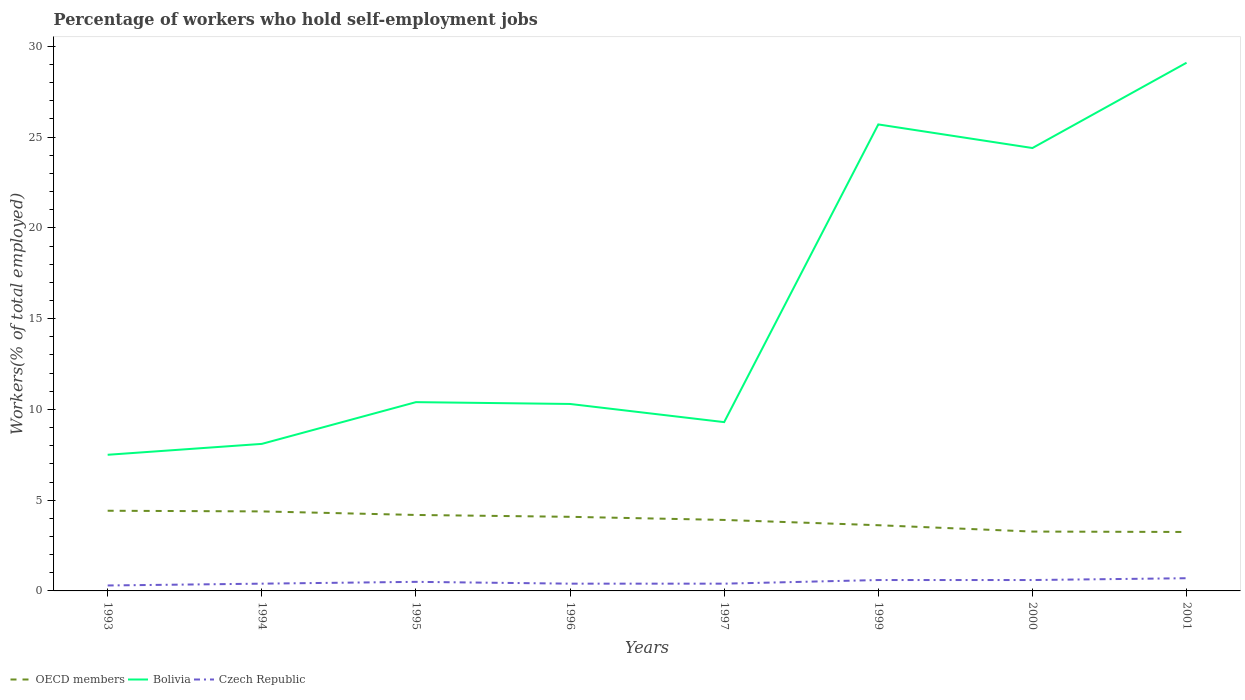How many different coloured lines are there?
Keep it short and to the point. 3. Across all years, what is the maximum percentage of self-employed workers in OECD members?
Keep it short and to the point. 3.25. In which year was the percentage of self-employed workers in OECD members maximum?
Provide a succinct answer. 2001. What is the total percentage of self-employed workers in Bolivia in the graph?
Your answer should be very brief. -14. What is the difference between the highest and the second highest percentage of self-employed workers in Czech Republic?
Ensure brevity in your answer.  0.4. What is the difference between the highest and the lowest percentage of self-employed workers in Czech Republic?
Give a very brief answer. 4. How many lines are there?
Offer a very short reply. 3. How many years are there in the graph?
Offer a very short reply. 8. What is the difference between two consecutive major ticks on the Y-axis?
Your answer should be compact. 5. Are the values on the major ticks of Y-axis written in scientific E-notation?
Offer a very short reply. No. Does the graph contain grids?
Your answer should be compact. No. Where does the legend appear in the graph?
Your answer should be compact. Bottom left. How are the legend labels stacked?
Your response must be concise. Horizontal. What is the title of the graph?
Offer a terse response. Percentage of workers who hold self-employment jobs. What is the label or title of the Y-axis?
Provide a short and direct response. Workers(% of total employed). What is the Workers(% of total employed) in OECD members in 1993?
Provide a short and direct response. 4.42. What is the Workers(% of total employed) in Bolivia in 1993?
Make the answer very short. 7.5. What is the Workers(% of total employed) of Czech Republic in 1993?
Your answer should be compact. 0.3. What is the Workers(% of total employed) in OECD members in 1994?
Provide a short and direct response. 4.38. What is the Workers(% of total employed) in Bolivia in 1994?
Provide a short and direct response. 8.1. What is the Workers(% of total employed) of Czech Republic in 1994?
Offer a terse response. 0.4. What is the Workers(% of total employed) in OECD members in 1995?
Give a very brief answer. 4.18. What is the Workers(% of total employed) of Bolivia in 1995?
Your answer should be very brief. 10.4. What is the Workers(% of total employed) in OECD members in 1996?
Make the answer very short. 4.08. What is the Workers(% of total employed) in Bolivia in 1996?
Provide a short and direct response. 10.3. What is the Workers(% of total employed) in Czech Republic in 1996?
Your answer should be compact. 0.4. What is the Workers(% of total employed) in OECD members in 1997?
Offer a terse response. 3.91. What is the Workers(% of total employed) of Bolivia in 1997?
Offer a very short reply. 9.3. What is the Workers(% of total employed) in Czech Republic in 1997?
Your answer should be very brief. 0.4. What is the Workers(% of total employed) of OECD members in 1999?
Make the answer very short. 3.62. What is the Workers(% of total employed) in Bolivia in 1999?
Provide a succinct answer. 25.7. What is the Workers(% of total employed) in Czech Republic in 1999?
Give a very brief answer. 0.6. What is the Workers(% of total employed) in OECD members in 2000?
Your answer should be very brief. 3.27. What is the Workers(% of total employed) of Bolivia in 2000?
Your answer should be very brief. 24.4. What is the Workers(% of total employed) in Czech Republic in 2000?
Ensure brevity in your answer.  0.6. What is the Workers(% of total employed) in OECD members in 2001?
Offer a very short reply. 3.25. What is the Workers(% of total employed) in Bolivia in 2001?
Provide a short and direct response. 29.1. What is the Workers(% of total employed) in Czech Republic in 2001?
Make the answer very short. 0.7. Across all years, what is the maximum Workers(% of total employed) in OECD members?
Provide a short and direct response. 4.42. Across all years, what is the maximum Workers(% of total employed) of Bolivia?
Ensure brevity in your answer.  29.1. Across all years, what is the maximum Workers(% of total employed) of Czech Republic?
Ensure brevity in your answer.  0.7. Across all years, what is the minimum Workers(% of total employed) of OECD members?
Give a very brief answer. 3.25. Across all years, what is the minimum Workers(% of total employed) in Czech Republic?
Your answer should be very brief. 0.3. What is the total Workers(% of total employed) of OECD members in the graph?
Your answer should be compact. 31.11. What is the total Workers(% of total employed) in Bolivia in the graph?
Your response must be concise. 124.8. What is the total Workers(% of total employed) in Czech Republic in the graph?
Make the answer very short. 3.9. What is the difference between the Workers(% of total employed) in OECD members in 1993 and that in 1994?
Provide a succinct answer. 0.04. What is the difference between the Workers(% of total employed) in Bolivia in 1993 and that in 1994?
Your answer should be compact. -0.6. What is the difference between the Workers(% of total employed) in Czech Republic in 1993 and that in 1994?
Your answer should be compact. -0.1. What is the difference between the Workers(% of total employed) of OECD members in 1993 and that in 1995?
Provide a succinct answer. 0.23. What is the difference between the Workers(% of total employed) of OECD members in 1993 and that in 1996?
Offer a very short reply. 0.33. What is the difference between the Workers(% of total employed) of Czech Republic in 1993 and that in 1996?
Your answer should be compact. -0.1. What is the difference between the Workers(% of total employed) in OECD members in 1993 and that in 1997?
Offer a terse response. 0.51. What is the difference between the Workers(% of total employed) in OECD members in 1993 and that in 1999?
Offer a very short reply. 0.8. What is the difference between the Workers(% of total employed) of Bolivia in 1993 and that in 1999?
Provide a succinct answer. -18.2. What is the difference between the Workers(% of total employed) of OECD members in 1993 and that in 2000?
Provide a short and direct response. 1.15. What is the difference between the Workers(% of total employed) in Bolivia in 1993 and that in 2000?
Keep it short and to the point. -16.9. What is the difference between the Workers(% of total employed) of Czech Republic in 1993 and that in 2000?
Offer a very short reply. -0.3. What is the difference between the Workers(% of total employed) in OECD members in 1993 and that in 2001?
Your response must be concise. 1.17. What is the difference between the Workers(% of total employed) of Bolivia in 1993 and that in 2001?
Offer a very short reply. -21.6. What is the difference between the Workers(% of total employed) in Czech Republic in 1993 and that in 2001?
Offer a very short reply. -0.4. What is the difference between the Workers(% of total employed) of OECD members in 1994 and that in 1995?
Offer a very short reply. 0.2. What is the difference between the Workers(% of total employed) of Bolivia in 1994 and that in 1995?
Your response must be concise. -2.3. What is the difference between the Workers(% of total employed) of OECD members in 1994 and that in 1996?
Provide a short and direct response. 0.3. What is the difference between the Workers(% of total employed) in Bolivia in 1994 and that in 1996?
Provide a short and direct response. -2.2. What is the difference between the Workers(% of total employed) of OECD members in 1994 and that in 1997?
Ensure brevity in your answer.  0.47. What is the difference between the Workers(% of total employed) of OECD members in 1994 and that in 1999?
Ensure brevity in your answer.  0.76. What is the difference between the Workers(% of total employed) in Bolivia in 1994 and that in 1999?
Your response must be concise. -17.6. What is the difference between the Workers(% of total employed) in Czech Republic in 1994 and that in 1999?
Offer a very short reply. -0.2. What is the difference between the Workers(% of total employed) of OECD members in 1994 and that in 2000?
Give a very brief answer. 1.11. What is the difference between the Workers(% of total employed) of Bolivia in 1994 and that in 2000?
Your answer should be very brief. -16.3. What is the difference between the Workers(% of total employed) of OECD members in 1994 and that in 2001?
Provide a short and direct response. 1.13. What is the difference between the Workers(% of total employed) in Czech Republic in 1994 and that in 2001?
Ensure brevity in your answer.  -0.3. What is the difference between the Workers(% of total employed) in OECD members in 1995 and that in 1996?
Ensure brevity in your answer.  0.1. What is the difference between the Workers(% of total employed) in OECD members in 1995 and that in 1997?
Your answer should be very brief. 0.27. What is the difference between the Workers(% of total employed) of Bolivia in 1995 and that in 1997?
Provide a short and direct response. 1.1. What is the difference between the Workers(% of total employed) in OECD members in 1995 and that in 1999?
Provide a short and direct response. 0.57. What is the difference between the Workers(% of total employed) in Bolivia in 1995 and that in 1999?
Offer a terse response. -15.3. What is the difference between the Workers(% of total employed) of OECD members in 1995 and that in 2000?
Your response must be concise. 0.92. What is the difference between the Workers(% of total employed) of Bolivia in 1995 and that in 2000?
Your response must be concise. -14. What is the difference between the Workers(% of total employed) of Czech Republic in 1995 and that in 2000?
Make the answer very short. -0.1. What is the difference between the Workers(% of total employed) of OECD members in 1995 and that in 2001?
Ensure brevity in your answer.  0.94. What is the difference between the Workers(% of total employed) in Bolivia in 1995 and that in 2001?
Keep it short and to the point. -18.7. What is the difference between the Workers(% of total employed) of OECD members in 1996 and that in 1997?
Offer a very short reply. 0.17. What is the difference between the Workers(% of total employed) in Bolivia in 1996 and that in 1997?
Keep it short and to the point. 1. What is the difference between the Workers(% of total employed) in OECD members in 1996 and that in 1999?
Keep it short and to the point. 0.46. What is the difference between the Workers(% of total employed) of Bolivia in 1996 and that in 1999?
Provide a succinct answer. -15.4. What is the difference between the Workers(% of total employed) of OECD members in 1996 and that in 2000?
Keep it short and to the point. 0.81. What is the difference between the Workers(% of total employed) in Bolivia in 1996 and that in 2000?
Offer a very short reply. -14.1. What is the difference between the Workers(% of total employed) in Czech Republic in 1996 and that in 2000?
Your answer should be very brief. -0.2. What is the difference between the Workers(% of total employed) in OECD members in 1996 and that in 2001?
Offer a terse response. 0.83. What is the difference between the Workers(% of total employed) in Bolivia in 1996 and that in 2001?
Keep it short and to the point. -18.8. What is the difference between the Workers(% of total employed) of OECD members in 1997 and that in 1999?
Offer a very short reply. 0.29. What is the difference between the Workers(% of total employed) in Bolivia in 1997 and that in 1999?
Offer a very short reply. -16.4. What is the difference between the Workers(% of total employed) in OECD members in 1997 and that in 2000?
Offer a terse response. 0.64. What is the difference between the Workers(% of total employed) of Bolivia in 1997 and that in 2000?
Ensure brevity in your answer.  -15.1. What is the difference between the Workers(% of total employed) of Czech Republic in 1997 and that in 2000?
Provide a succinct answer. -0.2. What is the difference between the Workers(% of total employed) of OECD members in 1997 and that in 2001?
Give a very brief answer. 0.66. What is the difference between the Workers(% of total employed) in Bolivia in 1997 and that in 2001?
Your answer should be very brief. -19.8. What is the difference between the Workers(% of total employed) of Czech Republic in 1997 and that in 2001?
Your answer should be compact. -0.3. What is the difference between the Workers(% of total employed) in OECD members in 1999 and that in 2000?
Provide a succinct answer. 0.35. What is the difference between the Workers(% of total employed) in Bolivia in 1999 and that in 2000?
Offer a very short reply. 1.3. What is the difference between the Workers(% of total employed) in OECD members in 1999 and that in 2001?
Offer a very short reply. 0.37. What is the difference between the Workers(% of total employed) in OECD members in 2000 and that in 2001?
Offer a terse response. 0.02. What is the difference between the Workers(% of total employed) of Czech Republic in 2000 and that in 2001?
Your answer should be compact. -0.1. What is the difference between the Workers(% of total employed) in OECD members in 1993 and the Workers(% of total employed) in Bolivia in 1994?
Keep it short and to the point. -3.68. What is the difference between the Workers(% of total employed) in OECD members in 1993 and the Workers(% of total employed) in Czech Republic in 1994?
Ensure brevity in your answer.  4.02. What is the difference between the Workers(% of total employed) of OECD members in 1993 and the Workers(% of total employed) of Bolivia in 1995?
Offer a terse response. -5.98. What is the difference between the Workers(% of total employed) in OECD members in 1993 and the Workers(% of total employed) in Czech Republic in 1995?
Your answer should be compact. 3.92. What is the difference between the Workers(% of total employed) of Bolivia in 1993 and the Workers(% of total employed) of Czech Republic in 1995?
Provide a succinct answer. 7. What is the difference between the Workers(% of total employed) of OECD members in 1993 and the Workers(% of total employed) of Bolivia in 1996?
Ensure brevity in your answer.  -5.88. What is the difference between the Workers(% of total employed) in OECD members in 1993 and the Workers(% of total employed) in Czech Republic in 1996?
Ensure brevity in your answer.  4.02. What is the difference between the Workers(% of total employed) in Bolivia in 1993 and the Workers(% of total employed) in Czech Republic in 1996?
Offer a terse response. 7.1. What is the difference between the Workers(% of total employed) of OECD members in 1993 and the Workers(% of total employed) of Bolivia in 1997?
Make the answer very short. -4.88. What is the difference between the Workers(% of total employed) of OECD members in 1993 and the Workers(% of total employed) of Czech Republic in 1997?
Your response must be concise. 4.02. What is the difference between the Workers(% of total employed) of OECD members in 1993 and the Workers(% of total employed) of Bolivia in 1999?
Your answer should be very brief. -21.28. What is the difference between the Workers(% of total employed) of OECD members in 1993 and the Workers(% of total employed) of Czech Republic in 1999?
Make the answer very short. 3.82. What is the difference between the Workers(% of total employed) in Bolivia in 1993 and the Workers(% of total employed) in Czech Republic in 1999?
Provide a short and direct response. 6.9. What is the difference between the Workers(% of total employed) in OECD members in 1993 and the Workers(% of total employed) in Bolivia in 2000?
Your answer should be compact. -19.98. What is the difference between the Workers(% of total employed) in OECD members in 1993 and the Workers(% of total employed) in Czech Republic in 2000?
Offer a very short reply. 3.82. What is the difference between the Workers(% of total employed) in OECD members in 1993 and the Workers(% of total employed) in Bolivia in 2001?
Provide a short and direct response. -24.68. What is the difference between the Workers(% of total employed) of OECD members in 1993 and the Workers(% of total employed) of Czech Republic in 2001?
Offer a very short reply. 3.72. What is the difference between the Workers(% of total employed) in OECD members in 1994 and the Workers(% of total employed) in Bolivia in 1995?
Offer a terse response. -6.02. What is the difference between the Workers(% of total employed) in OECD members in 1994 and the Workers(% of total employed) in Czech Republic in 1995?
Your answer should be very brief. 3.88. What is the difference between the Workers(% of total employed) of Bolivia in 1994 and the Workers(% of total employed) of Czech Republic in 1995?
Your response must be concise. 7.6. What is the difference between the Workers(% of total employed) in OECD members in 1994 and the Workers(% of total employed) in Bolivia in 1996?
Keep it short and to the point. -5.92. What is the difference between the Workers(% of total employed) of OECD members in 1994 and the Workers(% of total employed) of Czech Republic in 1996?
Your response must be concise. 3.98. What is the difference between the Workers(% of total employed) in Bolivia in 1994 and the Workers(% of total employed) in Czech Republic in 1996?
Your answer should be compact. 7.7. What is the difference between the Workers(% of total employed) in OECD members in 1994 and the Workers(% of total employed) in Bolivia in 1997?
Make the answer very short. -4.92. What is the difference between the Workers(% of total employed) of OECD members in 1994 and the Workers(% of total employed) of Czech Republic in 1997?
Provide a short and direct response. 3.98. What is the difference between the Workers(% of total employed) in Bolivia in 1994 and the Workers(% of total employed) in Czech Republic in 1997?
Provide a short and direct response. 7.7. What is the difference between the Workers(% of total employed) in OECD members in 1994 and the Workers(% of total employed) in Bolivia in 1999?
Keep it short and to the point. -21.32. What is the difference between the Workers(% of total employed) in OECD members in 1994 and the Workers(% of total employed) in Czech Republic in 1999?
Keep it short and to the point. 3.78. What is the difference between the Workers(% of total employed) in OECD members in 1994 and the Workers(% of total employed) in Bolivia in 2000?
Provide a short and direct response. -20.02. What is the difference between the Workers(% of total employed) in OECD members in 1994 and the Workers(% of total employed) in Czech Republic in 2000?
Your answer should be compact. 3.78. What is the difference between the Workers(% of total employed) in Bolivia in 1994 and the Workers(% of total employed) in Czech Republic in 2000?
Your response must be concise. 7.5. What is the difference between the Workers(% of total employed) of OECD members in 1994 and the Workers(% of total employed) of Bolivia in 2001?
Make the answer very short. -24.72. What is the difference between the Workers(% of total employed) of OECD members in 1994 and the Workers(% of total employed) of Czech Republic in 2001?
Keep it short and to the point. 3.68. What is the difference between the Workers(% of total employed) in OECD members in 1995 and the Workers(% of total employed) in Bolivia in 1996?
Provide a succinct answer. -6.12. What is the difference between the Workers(% of total employed) in OECD members in 1995 and the Workers(% of total employed) in Czech Republic in 1996?
Provide a succinct answer. 3.78. What is the difference between the Workers(% of total employed) in OECD members in 1995 and the Workers(% of total employed) in Bolivia in 1997?
Provide a short and direct response. -5.12. What is the difference between the Workers(% of total employed) in OECD members in 1995 and the Workers(% of total employed) in Czech Republic in 1997?
Your answer should be compact. 3.78. What is the difference between the Workers(% of total employed) of OECD members in 1995 and the Workers(% of total employed) of Bolivia in 1999?
Provide a short and direct response. -21.52. What is the difference between the Workers(% of total employed) of OECD members in 1995 and the Workers(% of total employed) of Czech Republic in 1999?
Provide a short and direct response. 3.58. What is the difference between the Workers(% of total employed) of Bolivia in 1995 and the Workers(% of total employed) of Czech Republic in 1999?
Provide a short and direct response. 9.8. What is the difference between the Workers(% of total employed) of OECD members in 1995 and the Workers(% of total employed) of Bolivia in 2000?
Offer a terse response. -20.22. What is the difference between the Workers(% of total employed) of OECD members in 1995 and the Workers(% of total employed) of Czech Republic in 2000?
Provide a short and direct response. 3.58. What is the difference between the Workers(% of total employed) in OECD members in 1995 and the Workers(% of total employed) in Bolivia in 2001?
Give a very brief answer. -24.92. What is the difference between the Workers(% of total employed) in OECD members in 1995 and the Workers(% of total employed) in Czech Republic in 2001?
Offer a terse response. 3.48. What is the difference between the Workers(% of total employed) in OECD members in 1996 and the Workers(% of total employed) in Bolivia in 1997?
Your answer should be very brief. -5.22. What is the difference between the Workers(% of total employed) in OECD members in 1996 and the Workers(% of total employed) in Czech Republic in 1997?
Offer a terse response. 3.68. What is the difference between the Workers(% of total employed) of Bolivia in 1996 and the Workers(% of total employed) of Czech Republic in 1997?
Your answer should be compact. 9.9. What is the difference between the Workers(% of total employed) of OECD members in 1996 and the Workers(% of total employed) of Bolivia in 1999?
Your answer should be very brief. -21.62. What is the difference between the Workers(% of total employed) in OECD members in 1996 and the Workers(% of total employed) in Czech Republic in 1999?
Offer a terse response. 3.48. What is the difference between the Workers(% of total employed) of Bolivia in 1996 and the Workers(% of total employed) of Czech Republic in 1999?
Offer a very short reply. 9.7. What is the difference between the Workers(% of total employed) in OECD members in 1996 and the Workers(% of total employed) in Bolivia in 2000?
Keep it short and to the point. -20.32. What is the difference between the Workers(% of total employed) of OECD members in 1996 and the Workers(% of total employed) of Czech Republic in 2000?
Provide a short and direct response. 3.48. What is the difference between the Workers(% of total employed) in Bolivia in 1996 and the Workers(% of total employed) in Czech Republic in 2000?
Your answer should be very brief. 9.7. What is the difference between the Workers(% of total employed) of OECD members in 1996 and the Workers(% of total employed) of Bolivia in 2001?
Ensure brevity in your answer.  -25.02. What is the difference between the Workers(% of total employed) in OECD members in 1996 and the Workers(% of total employed) in Czech Republic in 2001?
Provide a short and direct response. 3.38. What is the difference between the Workers(% of total employed) of OECD members in 1997 and the Workers(% of total employed) of Bolivia in 1999?
Your answer should be very brief. -21.79. What is the difference between the Workers(% of total employed) in OECD members in 1997 and the Workers(% of total employed) in Czech Republic in 1999?
Your response must be concise. 3.31. What is the difference between the Workers(% of total employed) of OECD members in 1997 and the Workers(% of total employed) of Bolivia in 2000?
Your response must be concise. -20.49. What is the difference between the Workers(% of total employed) of OECD members in 1997 and the Workers(% of total employed) of Czech Republic in 2000?
Your answer should be compact. 3.31. What is the difference between the Workers(% of total employed) in OECD members in 1997 and the Workers(% of total employed) in Bolivia in 2001?
Ensure brevity in your answer.  -25.19. What is the difference between the Workers(% of total employed) of OECD members in 1997 and the Workers(% of total employed) of Czech Republic in 2001?
Offer a terse response. 3.21. What is the difference between the Workers(% of total employed) of Bolivia in 1997 and the Workers(% of total employed) of Czech Republic in 2001?
Provide a short and direct response. 8.6. What is the difference between the Workers(% of total employed) of OECD members in 1999 and the Workers(% of total employed) of Bolivia in 2000?
Your answer should be compact. -20.78. What is the difference between the Workers(% of total employed) in OECD members in 1999 and the Workers(% of total employed) in Czech Republic in 2000?
Make the answer very short. 3.02. What is the difference between the Workers(% of total employed) in Bolivia in 1999 and the Workers(% of total employed) in Czech Republic in 2000?
Make the answer very short. 25.1. What is the difference between the Workers(% of total employed) of OECD members in 1999 and the Workers(% of total employed) of Bolivia in 2001?
Ensure brevity in your answer.  -25.48. What is the difference between the Workers(% of total employed) of OECD members in 1999 and the Workers(% of total employed) of Czech Republic in 2001?
Your answer should be very brief. 2.92. What is the difference between the Workers(% of total employed) of Bolivia in 1999 and the Workers(% of total employed) of Czech Republic in 2001?
Provide a short and direct response. 25. What is the difference between the Workers(% of total employed) in OECD members in 2000 and the Workers(% of total employed) in Bolivia in 2001?
Ensure brevity in your answer.  -25.83. What is the difference between the Workers(% of total employed) of OECD members in 2000 and the Workers(% of total employed) of Czech Republic in 2001?
Provide a succinct answer. 2.57. What is the difference between the Workers(% of total employed) of Bolivia in 2000 and the Workers(% of total employed) of Czech Republic in 2001?
Keep it short and to the point. 23.7. What is the average Workers(% of total employed) of OECD members per year?
Keep it short and to the point. 3.89. What is the average Workers(% of total employed) in Czech Republic per year?
Keep it short and to the point. 0.49. In the year 1993, what is the difference between the Workers(% of total employed) of OECD members and Workers(% of total employed) of Bolivia?
Provide a succinct answer. -3.08. In the year 1993, what is the difference between the Workers(% of total employed) of OECD members and Workers(% of total employed) of Czech Republic?
Your answer should be very brief. 4.12. In the year 1994, what is the difference between the Workers(% of total employed) of OECD members and Workers(% of total employed) of Bolivia?
Give a very brief answer. -3.72. In the year 1994, what is the difference between the Workers(% of total employed) of OECD members and Workers(% of total employed) of Czech Republic?
Your response must be concise. 3.98. In the year 1994, what is the difference between the Workers(% of total employed) of Bolivia and Workers(% of total employed) of Czech Republic?
Your answer should be very brief. 7.7. In the year 1995, what is the difference between the Workers(% of total employed) of OECD members and Workers(% of total employed) of Bolivia?
Provide a succinct answer. -6.22. In the year 1995, what is the difference between the Workers(% of total employed) in OECD members and Workers(% of total employed) in Czech Republic?
Keep it short and to the point. 3.68. In the year 1996, what is the difference between the Workers(% of total employed) of OECD members and Workers(% of total employed) of Bolivia?
Give a very brief answer. -6.22. In the year 1996, what is the difference between the Workers(% of total employed) of OECD members and Workers(% of total employed) of Czech Republic?
Give a very brief answer. 3.68. In the year 1997, what is the difference between the Workers(% of total employed) of OECD members and Workers(% of total employed) of Bolivia?
Your answer should be very brief. -5.39. In the year 1997, what is the difference between the Workers(% of total employed) of OECD members and Workers(% of total employed) of Czech Republic?
Your answer should be compact. 3.51. In the year 1997, what is the difference between the Workers(% of total employed) of Bolivia and Workers(% of total employed) of Czech Republic?
Offer a very short reply. 8.9. In the year 1999, what is the difference between the Workers(% of total employed) of OECD members and Workers(% of total employed) of Bolivia?
Give a very brief answer. -22.08. In the year 1999, what is the difference between the Workers(% of total employed) in OECD members and Workers(% of total employed) in Czech Republic?
Your response must be concise. 3.02. In the year 1999, what is the difference between the Workers(% of total employed) of Bolivia and Workers(% of total employed) of Czech Republic?
Provide a succinct answer. 25.1. In the year 2000, what is the difference between the Workers(% of total employed) of OECD members and Workers(% of total employed) of Bolivia?
Your answer should be very brief. -21.13. In the year 2000, what is the difference between the Workers(% of total employed) in OECD members and Workers(% of total employed) in Czech Republic?
Keep it short and to the point. 2.67. In the year 2000, what is the difference between the Workers(% of total employed) of Bolivia and Workers(% of total employed) of Czech Republic?
Ensure brevity in your answer.  23.8. In the year 2001, what is the difference between the Workers(% of total employed) in OECD members and Workers(% of total employed) in Bolivia?
Your response must be concise. -25.85. In the year 2001, what is the difference between the Workers(% of total employed) of OECD members and Workers(% of total employed) of Czech Republic?
Provide a short and direct response. 2.55. In the year 2001, what is the difference between the Workers(% of total employed) of Bolivia and Workers(% of total employed) of Czech Republic?
Provide a succinct answer. 28.4. What is the ratio of the Workers(% of total employed) in OECD members in 1993 to that in 1994?
Your answer should be compact. 1.01. What is the ratio of the Workers(% of total employed) in Bolivia in 1993 to that in 1994?
Your answer should be compact. 0.93. What is the ratio of the Workers(% of total employed) of Czech Republic in 1993 to that in 1994?
Offer a terse response. 0.75. What is the ratio of the Workers(% of total employed) in OECD members in 1993 to that in 1995?
Ensure brevity in your answer.  1.06. What is the ratio of the Workers(% of total employed) in Bolivia in 1993 to that in 1995?
Offer a very short reply. 0.72. What is the ratio of the Workers(% of total employed) in Czech Republic in 1993 to that in 1995?
Offer a terse response. 0.6. What is the ratio of the Workers(% of total employed) of OECD members in 1993 to that in 1996?
Give a very brief answer. 1.08. What is the ratio of the Workers(% of total employed) in Bolivia in 1993 to that in 1996?
Your answer should be compact. 0.73. What is the ratio of the Workers(% of total employed) in OECD members in 1993 to that in 1997?
Your answer should be very brief. 1.13. What is the ratio of the Workers(% of total employed) in Bolivia in 1993 to that in 1997?
Your answer should be very brief. 0.81. What is the ratio of the Workers(% of total employed) of Czech Republic in 1993 to that in 1997?
Give a very brief answer. 0.75. What is the ratio of the Workers(% of total employed) of OECD members in 1993 to that in 1999?
Make the answer very short. 1.22. What is the ratio of the Workers(% of total employed) in Bolivia in 1993 to that in 1999?
Provide a short and direct response. 0.29. What is the ratio of the Workers(% of total employed) in Czech Republic in 1993 to that in 1999?
Ensure brevity in your answer.  0.5. What is the ratio of the Workers(% of total employed) of OECD members in 1993 to that in 2000?
Provide a short and direct response. 1.35. What is the ratio of the Workers(% of total employed) in Bolivia in 1993 to that in 2000?
Keep it short and to the point. 0.31. What is the ratio of the Workers(% of total employed) in OECD members in 1993 to that in 2001?
Your response must be concise. 1.36. What is the ratio of the Workers(% of total employed) in Bolivia in 1993 to that in 2001?
Your response must be concise. 0.26. What is the ratio of the Workers(% of total employed) of Czech Republic in 1993 to that in 2001?
Offer a terse response. 0.43. What is the ratio of the Workers(% of total employed) in OECD members in 1994 to that in 1995?
Your response must be concise. 1.05. What is the ratio of the Workers(% of total employed) of Bolivia in 1994 to that in 1995?
Provide a short and direct response. 0.78. What is the ratio of the Workers(% of total employed) of Czech Republic in 1994 to that in 1995?
Give a very brief answer. 0.8. What is the ratio of the Workers(% of total employed) of OECD members in 1994 to that in 1996?
Ensure brevity in your answer.  1.07. What is the ratio of the Workers(% of total employed) of Bolivia in 1994 to that in 1996?
Your response must be concise. 0.79. What is the ratio of the Workers(% of total employed) in Czech Republic in 1994 to that in 1996?
Provide a short and direct response. 1. What is the ratio of the Workers(% of total employed) of OECD members in 1994 to that in 1997?
Make the answer very short. 1.12. What is the ratio of the Workers(% of total employed) of Bolivia in 1994 to that in 1997?
Make the answer very short. 0.87. What is the ratio of the Workers(% of total employed) of Czech Republic in 1994 to that in 1997?
Give a very brief answer. 1. What is the ratio of the Workers(% of total employed) of OECD members in 1994 to that in 1999?
Provide a short and direct response. 1.21. What is the ratio of the Workers(% of total employed) of Bolivia in 1994 to that in 1999?
Your response must be concise. 0.32. What is the ratio of the Workers(% of total employed) of OECD members in 1994 to that in 2000?
Your answer should be compact. 1.34. What is the ratio of the Workers(% of total employed) of Bolivia in 1994 to that in 2000?
Your answer should be compact. 0.33. What is the ratio of the Workers(% of total employed) in Czech Republic in 1994 to that in 2000?
Your answer should be very brief. 0.67. What is the ratio of the Workers(% of total employed) of OECD members in 1994 to that in 2001?
Provide a succinct answer. 1.35. What is the ratio of the Workers(% of total employed) in Bolivia in 1994 to that in 2001?
Provide a short and direct response. 0.28. What is the ratio of the Workers(% of total employed) in OECD members in 1995 to that in 1996?
Offer a terse response. 1.02. What is the ratio of the Workers(% of total employed) in Bolivia in 1995 to that in 1996?
Your answer should be very brief. 1.01. What is the ratio of the Workers(% of total employed) in Czech Republic in 1995 to that in 1996?
Offer a very short reply. 1.25. What is the ratio of the Workers(% of total employed) of OECD members in 1995 to that in 1997?
Provide a succinct answer. 1.07. What is the ratio of the Workers(% of total employed) in Bolivia in 1995 to that in 1997?
Give a very brief answer. 1.12. What is the ratio of the Workers(% of total employed) in OECD members in 1995 to that in 1999?
Provide a short and direct response. 1.16. What is the ratio of the Workers(% of total employed) in Bolivia in 1995 to that in 1999?
Keep it short and to the point. 0.4. What is the ratio of the Workers(% of total employed) in Czech Republic in 1995 to that in 1999?
Keep it short and to the point. 0.83. What is the ratio of the Workers(% of total employed) of OECD members in 1995 to that in 2000?
Your response must be concise. 1.28. What is the ratio of the Workers(% of total employed) of Bolivia in 1995 to that in 2000?
Provide a short and direct response. 0.43. What is the ratio of the Workers(% of total employed) in OECD members in 1995 to that in 2001?
Your answer should be very brief. 1.29. What is the ratio of the Workers(% of total employed) of Bolivia in 1995 to that in 2001?
Your answer should be compact. 0.36. What is the ratio of the Workers(% of total employed) of OECD members in 1996 to that in 1997?
Make the answer very short. 1.04. What is the ratio of the Workers(% of total employed) in Bolivia in 1996 to that in 1997?
Keep it short and to the point. 1.11. What is the ratio of the Workers(% of total employed) in Czech Republic in 1996 to that in 1997?
Your response must be concise. 1. What is the ratio of the Workers(% of total employed) of OECD members in 1996 to that in 1999?
Your answer should be very brief. 1.13. What is the ratio of the Workers(% of total employed) of Bolivia in 1996 to that in 1999?
Offer a terse response. 0.4. What is the ratio of the Workers(% of total employed) in Czech Republic in 1996 to that in 1999?
Offer a very short reply. 0.67. What is the ratio of the Workers(% of total employed) of OECD members in 1996 to that in 2000?
Your response must be concise. 1.25. What is the ratio of the Workers(% of total employed) in Bolivia in 1996 to that in 2000?
Offer a very short reply. 0.42. What is the ratio of the Workers(% of total employed) in Czech Republic in 1996 to that in 2000?
Ensure brevity in your answer.  0.67. What is the ratio of the Workers(% of total employed) of OECD members in 1996 to that in 2001?
Keep it short and to the point. 1.26. What is the ratio of the Workers(% of total employed) of Bolivia in 1996 to that in 2001?
Ensure brevity in your answer.  0.35. What is the ratio of the Workers(% of total employed) of Czech Republic in 1996 to that in 2001?
Your answer should be very brief. 0.57. What is the ratio of the Workers(% of total employed) in OECD members in 1997 to that in 1999?
Offer a very short reply. 1.08. What is the ratio of the Workers(% of total employed) in Bolivia in 1997 to that in 1999?
Your answer should be compact. 0.36. What is the ratio of the Workers(% of total employed) of OECD members in 1997 to that in 2000?
Your response must be concise. 1.2. What is the ratio of the Workers(% of total employed) of Bolivia in 1997 to that in 2000?
Your response must be concise. 0.38. What is the ratio of the Workers(% of total employed) of Czech Republic in 1997 to that in 2000?
Provide a succinct answer. 0.67. What is the ratio of the Workers(% of total employed) in OECD members in 1997 to that in 2001?
Keep it short and to the point. 1.2. What is the ratio of the Workers(% of total employed) of Bolivia in 1997 to that in 2001?
Your answer should be very brief. 0.32. What is the ratio of the Workers(% of total employed) of OECD members in 1999 to that in 2000?
Your answer should be very brief. 1.11. What is the ratio of the Workers(% of total employed) of Bolivia in 1999 to that in 2000?
Offer a terse response. 1.05. What is the ratio of the Workers(% of total employed) in OECD members in 1999 to that in 2001?
Offer a terse response. 1.11. What is the ratio of the Workers(% of total employed) in Bolivia in 1999 to that in 2001?
Offer a terse response. 0.88. What is the ratio of the Workers(% of total employed) of Czech Republic in 1999 to that in 2001?
Offer a very short reply. 0.86. What is the ratio of the Workers(% of total employed) of Bolivia in 2000 to that in 2001?
Give a very brief answer. 0.84. What is the ratio of the Workers(% of total employed) in Czech Republic in 2000 to that in 2001?
Your response must be concise. 0.86. What is the difference between the highest and the second highest Workers(% of total employed) in OECD members?
Keep it short and to the point. 0.04. What is the difference between the highest and the lowest Workers(% of total employed) of OECD members?
Ensure brevity in your answer.  1.17. What is the difference between the highest and the lowest Workers(% of total employed) in Bolivia?
Provide a succinct answer. 21.6. 